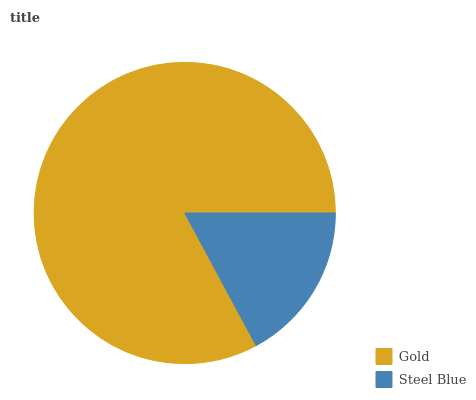Is Steel Blue the minimum?
Answer yes or no. Yes. Is Gold the maximum?
Answer yes or no. Yes. Is Steel Blue the maximum?
Answer yes or no. No. Is Gold greater than Steel Blue?
Answer yes or no. Yes. Is Steel Blue less than Gold?
Answer yes or no. Yes. Is Steel Blue greater than Gold?
Answer yes or no. No. Is Gold less than Steel Blue?
Answer yes or no. No. Is Gold the high median?
Answer yes or no. Yes. Is Steel Blue the low median?
Answer yes or no. Yes. Is Steel Blue the high median?
Answer yes or no. No. Is Gold the low median?
Answer yes or no. No. 